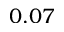<formula> <loc_0><loc_0><loc_500><loc_500>0 . 0 7</formula> 